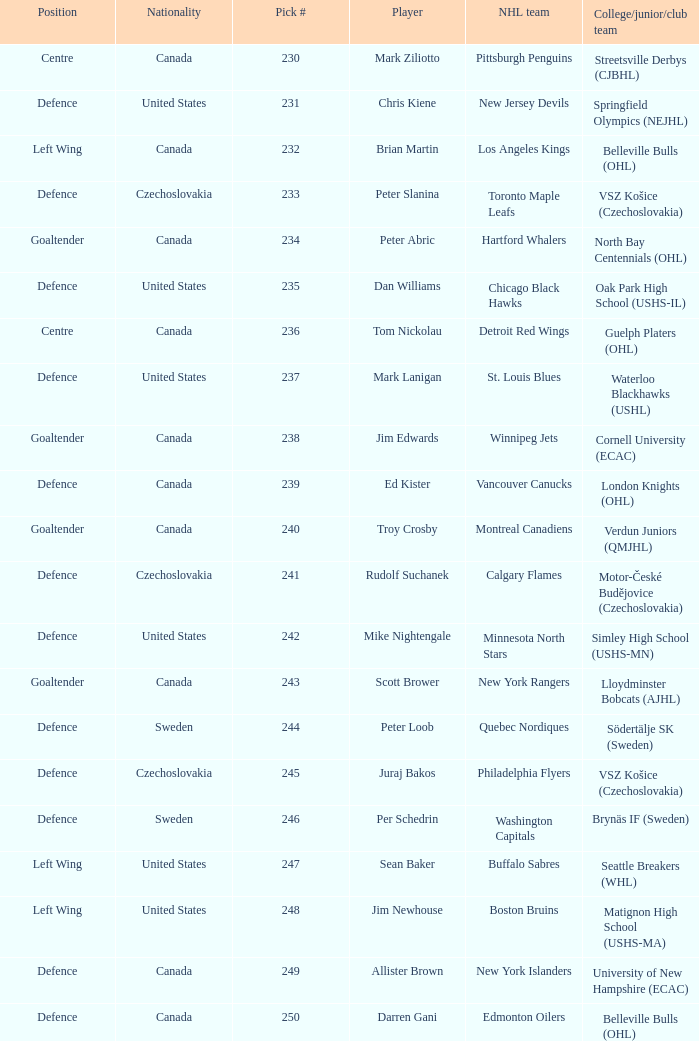Which draft number did the new jersey devils get? 231.0. 